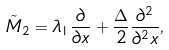<formula> <loc_0><loc_0><loc_500><loc_500>\tilde { M } _ { 2 } = \lambda _ { 1 } \frac { \partial } { \partial x } + \frac { \Delta } { 2 } \frac { \partial ^ { 2 } } { \partial ^ { 2 } x } ,</formula> 